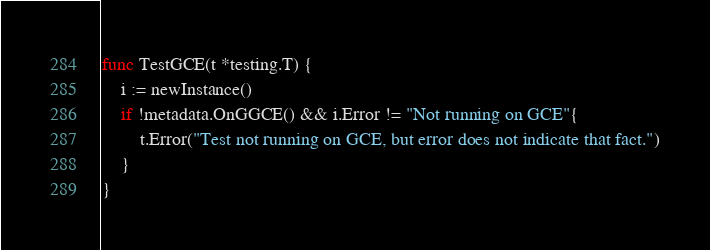Convert code to text. <code><loc_0><loc_0><loc_500><loc_500><_Go_>
func TestGCE(t *testing.T) {
	i := newInstance()
	if !metadata.OnGGCE() && i.Error != "Not running on GCE"{
		t.Error("Test not running on GCE, but error does not indicate that fact.")
	}
}
</code> 